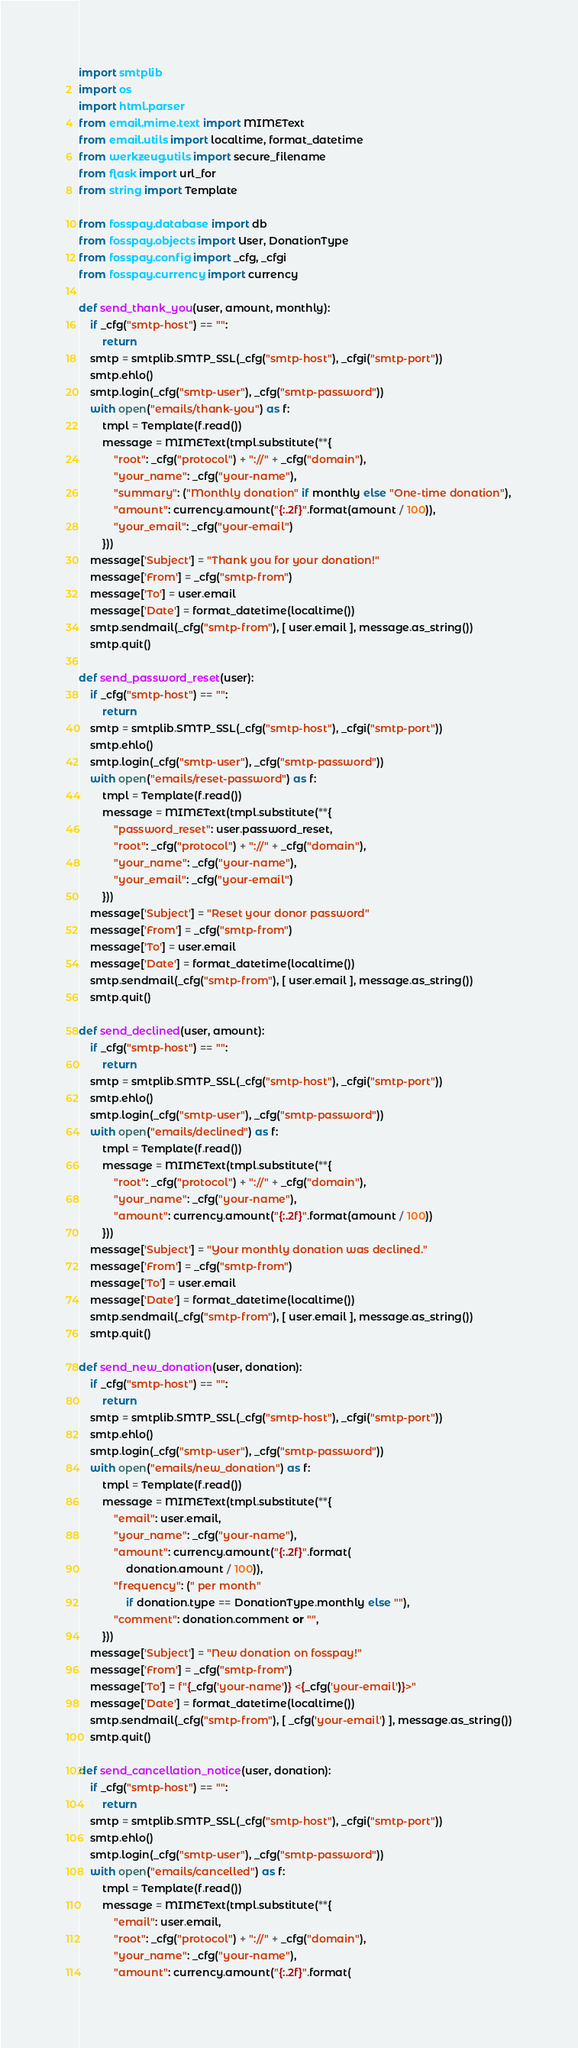<code> <loc_0><loc_0><loc_500><loc_500><_Python_>import smtplib
import os
import html.parser
from email.mime.text import MIMEText
from email.utils import localtime, format_datetime
from werkzeug.utils import secure_filename
from flask import url_for
from string import Template

from fosspay.database import db
from fosspay.objects import User, DonationType
from fosspay.config import _cfg, _cfgi
from fosspay.currency import currency

def send_thank_you(user, amount, monthly):
    if _cfg("smtp-host") == "":
        return
    smtp = smtplib.SMTP_SSL(_cfg("smtp-host"), _cfgi("smtp-port"))
    smtp.ehlo()
    smtp.login(_cfg("smtp-user"), _cfg("smtp-password"))
    with open("emails/thank-you") as f:
        tmpl = Template(f.read())
        message = MIMEText(tmpl.substitute(**{
            "root": _cfg("protocol") + "://" + _cfg("domain"),
            "your_name": _cfg("your-name"),
            "summary": ("Monthly donation" if monthly else "One-time donation"),
            "amount": currency.amount("{:.2f}".format(amount / 100)),
            "your_email": _cfg("your-email")
        }))
    message['Subject'] = "Thank you for your donation!"
    message['From'] = _cfg("smtp-from")
    message['To'] = user.email
    message['Date'] = format_datetime(localtime())
    smtp.sendmail(_cfg("smtp-from"), [ user.email ], message.as_string())
    smtp.quit()

def send_password_reset(user):
    if _cfg("smtp-host") == "":
        return
    smtp = smtplib.SMTP_SSL(_cfg("smtp-host"), _cfgi("smtp-port"))
    smtp.ehlo()
    smtp.login(_cfg("smtp-user"), _cfg("smtp-password"))
    with open("emails/reset-password") as f:
        tmpl = Template(f.read())
        message = MIMEText(tmpl.substitute(**{
            "password_reset": user.password_reset,
            "root": _cfg("protocol") + "://" + _cfg("domain"),
            "your_name": _cfg("your-name"),
            "your_email": _cfg("your-email")
        }))
    message['Subject'] = "Reset your donor password"
    message['From'] = _cfg("smtp-from")
    message['To'] = user.email
    message['Date'] = format_datetime(localtime())
    smtp.sendmail(_cfg("smtp-from"), [ user.email ], message.as_string())
    smtp.quit()

def send_declined(user, amount):
    if _cfg("smtp-host") == "":
        return
    smtp = smtplib.SMTP_SSL(_cfg("smtp-host"), _cfgi("smtp-port"))
    smtp.ehlo()
    smtp.login(_cfg("smtp-user"), _cfg("smtp-password"))
    with open("emails/declined") as f:
        tmpl = Template(f.read())
        message = MIMEText(tmpl.substitute(**{
            "root": _cfg("protocol") + "://" + _cfg("domain"),
            "your_name": _cfg("your-name"),
            "amount": currency.amount("{:.2f}".format(amount / 100))
        }))
    message['Subject'] = "Your monthly donation was declined."
    message['From'] = _cfg("smtp-from")
    message['To'] = user.email
    message['Date'] = format_datetime(localtime())
    smtp.sendmail(_cfg("smtp-from"), [ user.email ], message.as_string())
    smtp.quit()

def send_new_donation(user, donation):
    if _cfg("smtp-host") == "":
        return
    smtp = smtplib.SMTP_SSL(_cfg("smtp-host"), _cfgi("smtp-port"))
    smtp.ehlo()
    smtp.login(_cfg("smtp-user"), _cfg("smtp-password"))
    with open("emails/new_donation") as f:
        tmpl = Template(f.read())
        message = MIMEText(tmpl.substitute(**{
            "email": user.email,
            "your_name": _cfg("your-name"),
            "amount": currency.amount("{:.2f}".format(
                donation.amount / 100)),
            "frequency": (" per month"
                if donation.type == DonationType.monthly else ""),
            "comment": donation.comment or "",
        }))
    message['Subject'] = "New donation on fosspay!"
    message['From'] = _cfg("smtp-from")
    message['To'] = f"{_cfg('your-name')} <{_cfg('your-email')}>"
    message['Date'] = format_datetime(localtime())
    smtp.sendmail(_cfg("smtp-from"), [ _cfg('your-email') ], message.as_string())
    smtp.quit()

def send_cancellation_notice(user, donation):
    if _cfg("smtp-host") == "":
        return
    smtp = smtplib.SMTP_SSL(_cfg("smtp-host"), _cfgi("smtp-port"))
    smtp.ehlo()
    smtp.login(_cfg("smtp-user"), _cfg("smtp-password"))
    with open("emails/cancelled") as f:
        tmpl = Template(f.read())
        message = MIMEText(tmpl.substitute(**{
            "email": user.email,
            "root": _cfg("protocol") + "://" + _cfg("domain"),
            "your_name": _cfg("your-name"),
            "amount": currency.amount("{:.2f}".format(</code> 